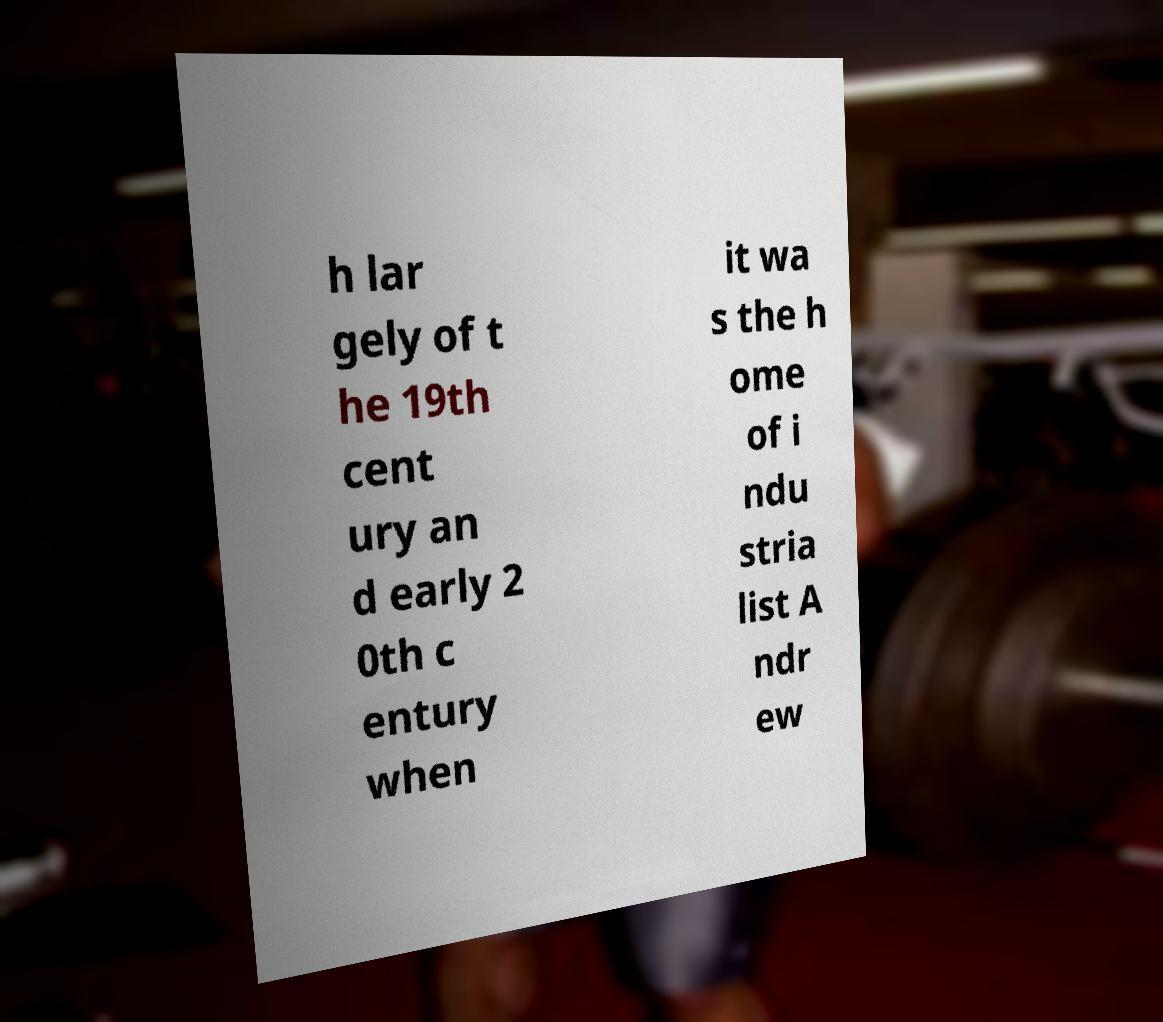Could you extract and type out the text from this image? h lar gely of t he 19th cent ury an d early 2 0th c entury when it wa s the h ome of i ndu stria list A ndr ew 